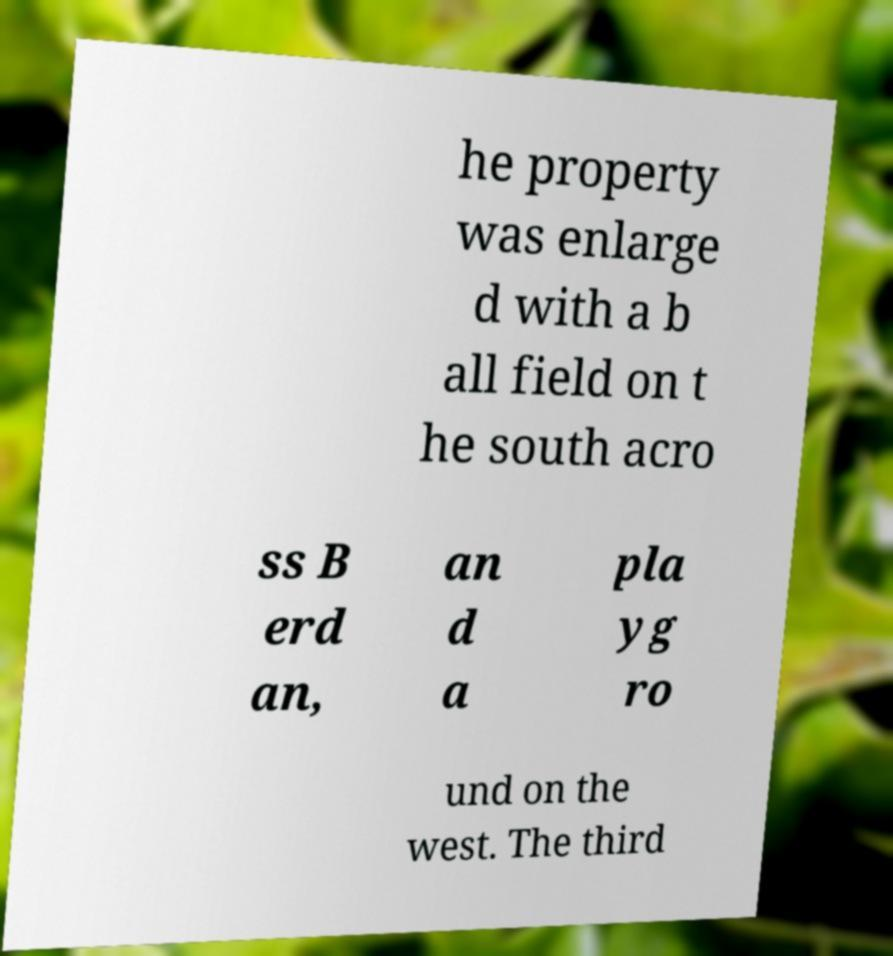Please identify and transcribe the text found in this image. he property was enlarge d with a b all field on t he south acro ss B erd an, an d a pla yg ro und on the west. The third 